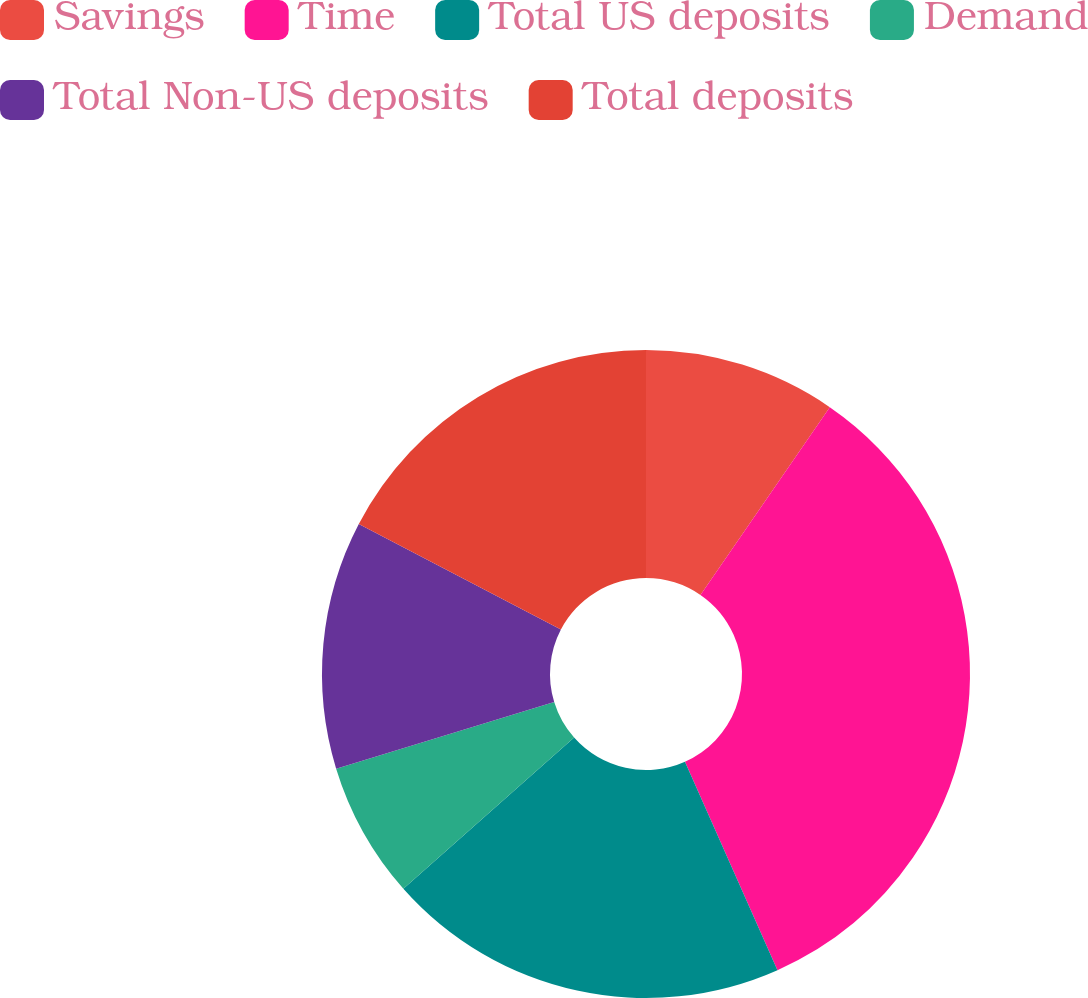Convert chart. <chart><loc_0><loc_0><loc_500><loc_500><pie_chart><fcel>Savings<fcel>Time<fcel>Total US deposits<fcel>Demand<fcel>Total Non-US deposits<fcel>Total deposits<nl><fcel>9.6%<fcel>33.75%<fcel>20.12%<fcel>6.81%<fcel>12.38%<fcel>17.34%<nl></chart> 